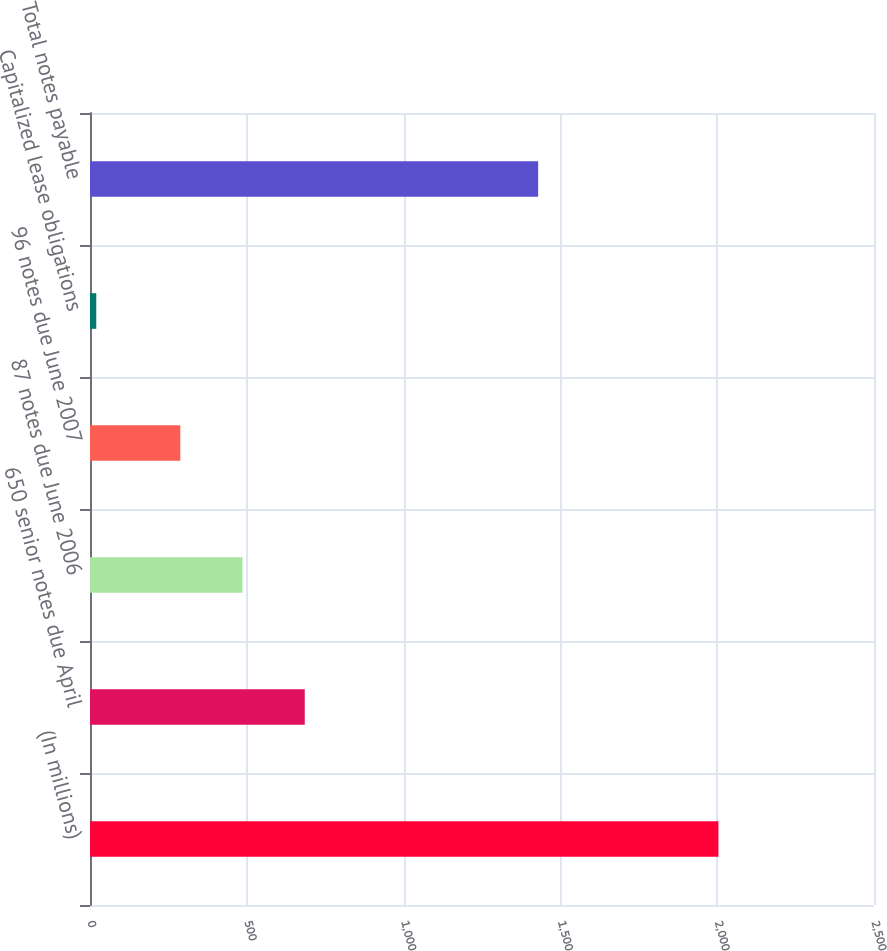Convert chart. <chart><loc_0><loc_0><loc_500><loc_500><bar_chart><fcel>(In millions)<fcel>650 senior notes due April<fcel>87 notes due June 2006<fcel>96 notes due June 2007<fcel>Capitalized lease obligations<fcel>Total notes payable<nl><fcel>2004<fcel>684.8<fcel>486.4<fcel>288<fcel>20<fcel>1429<nl></chart> 